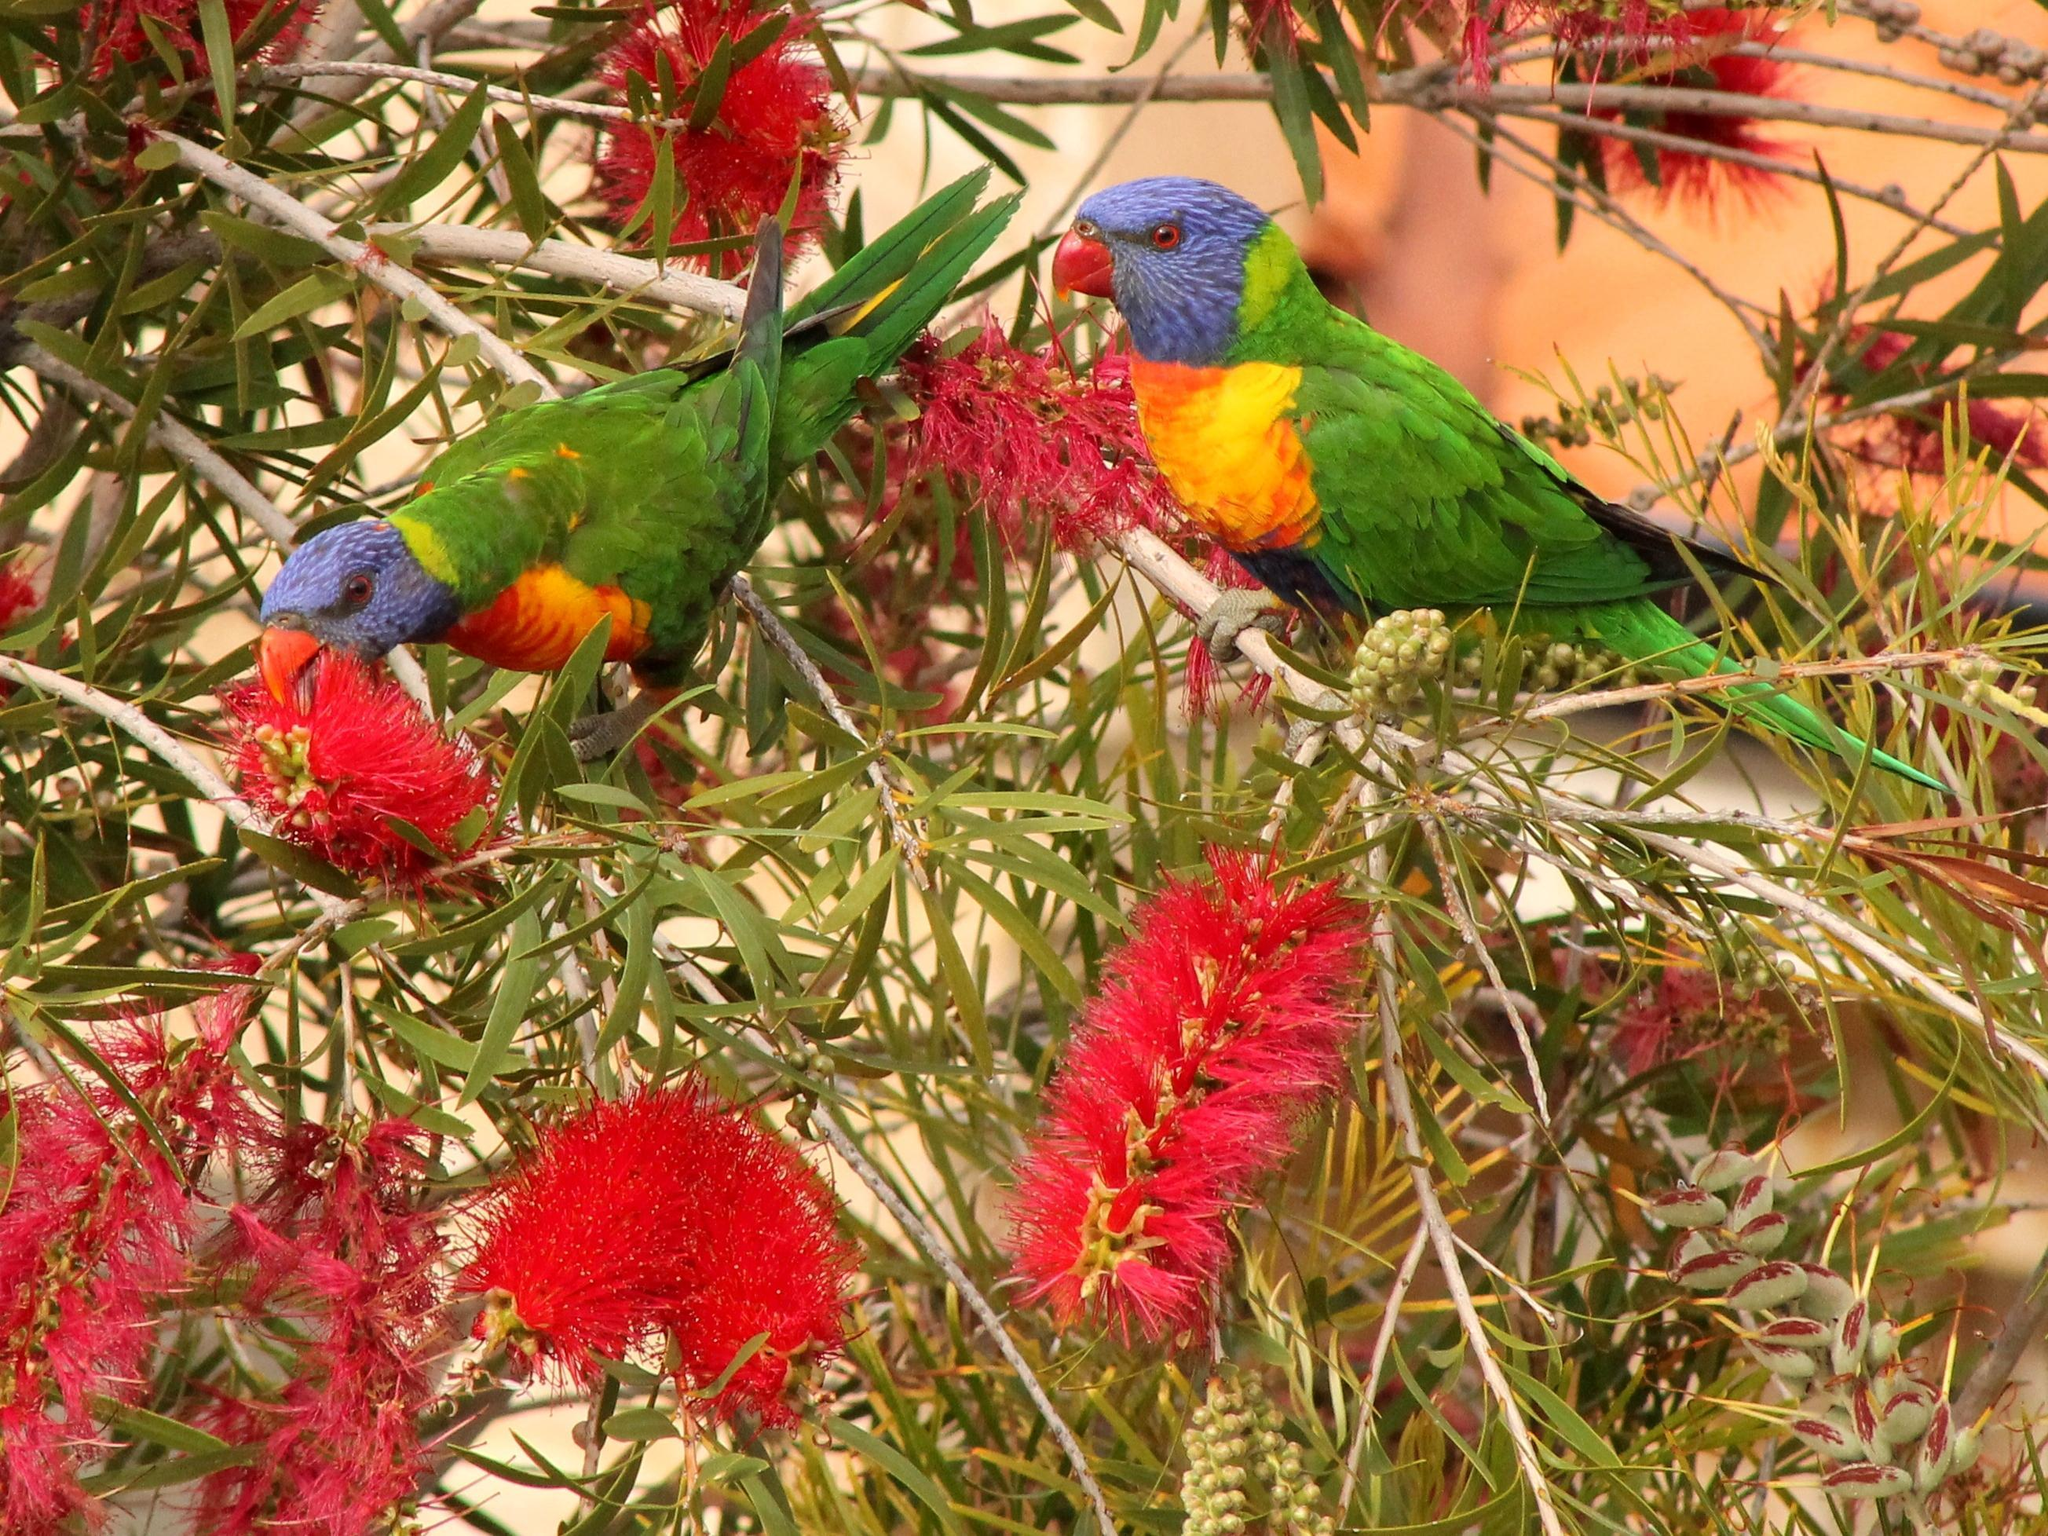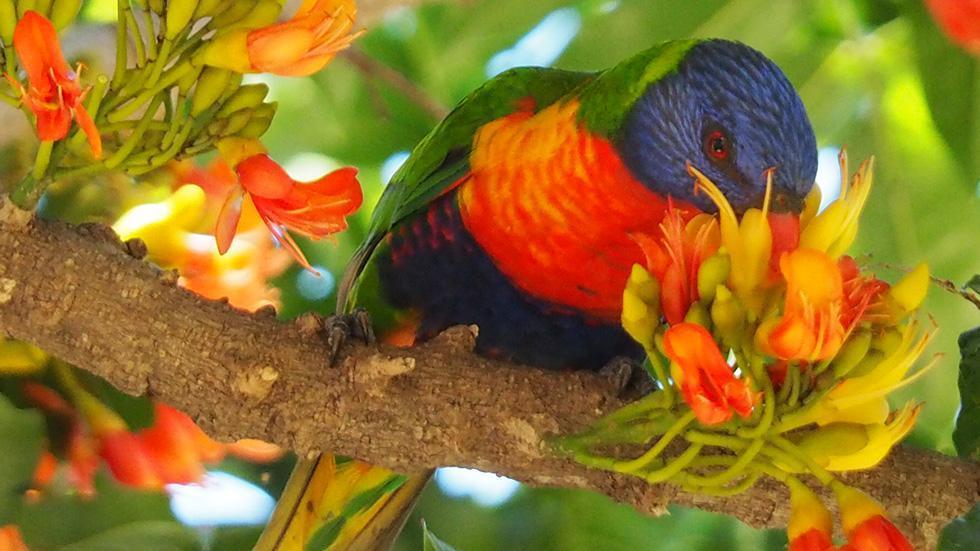The first image is the image on the left, the second image is the image on the right. Examine the images to the left and right. Is the description "Two birds are facing the same direction." accurate? Answer yes or no. Yes. The first image is the image on the left, the second image is the image on the right. For the images displayed, is the sentence "An image shows exactly one parrot perched among branches of red flowers with tendril petals." factually correct? Answer yes or no. No. 